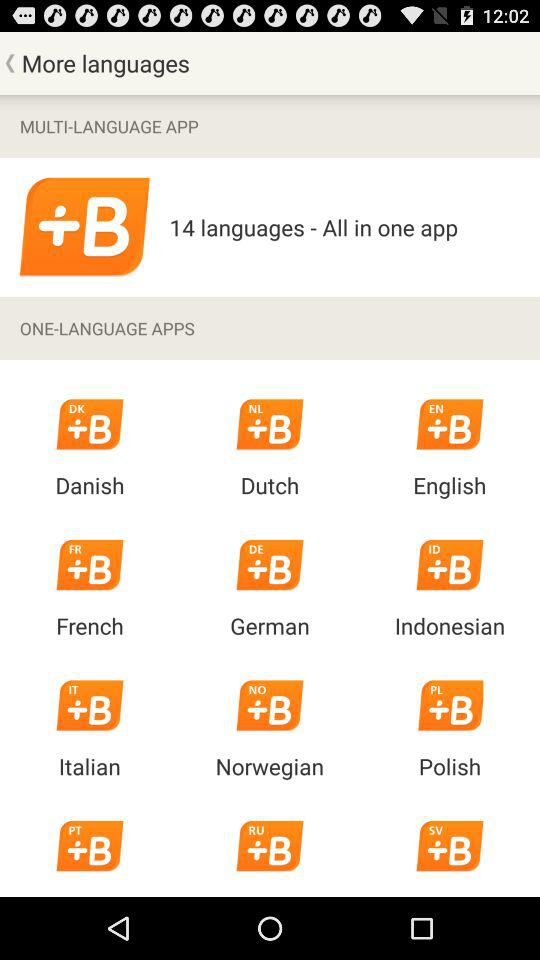How many languages are available as multi-language apps?
Answer the question using a single word or phrase. 14 